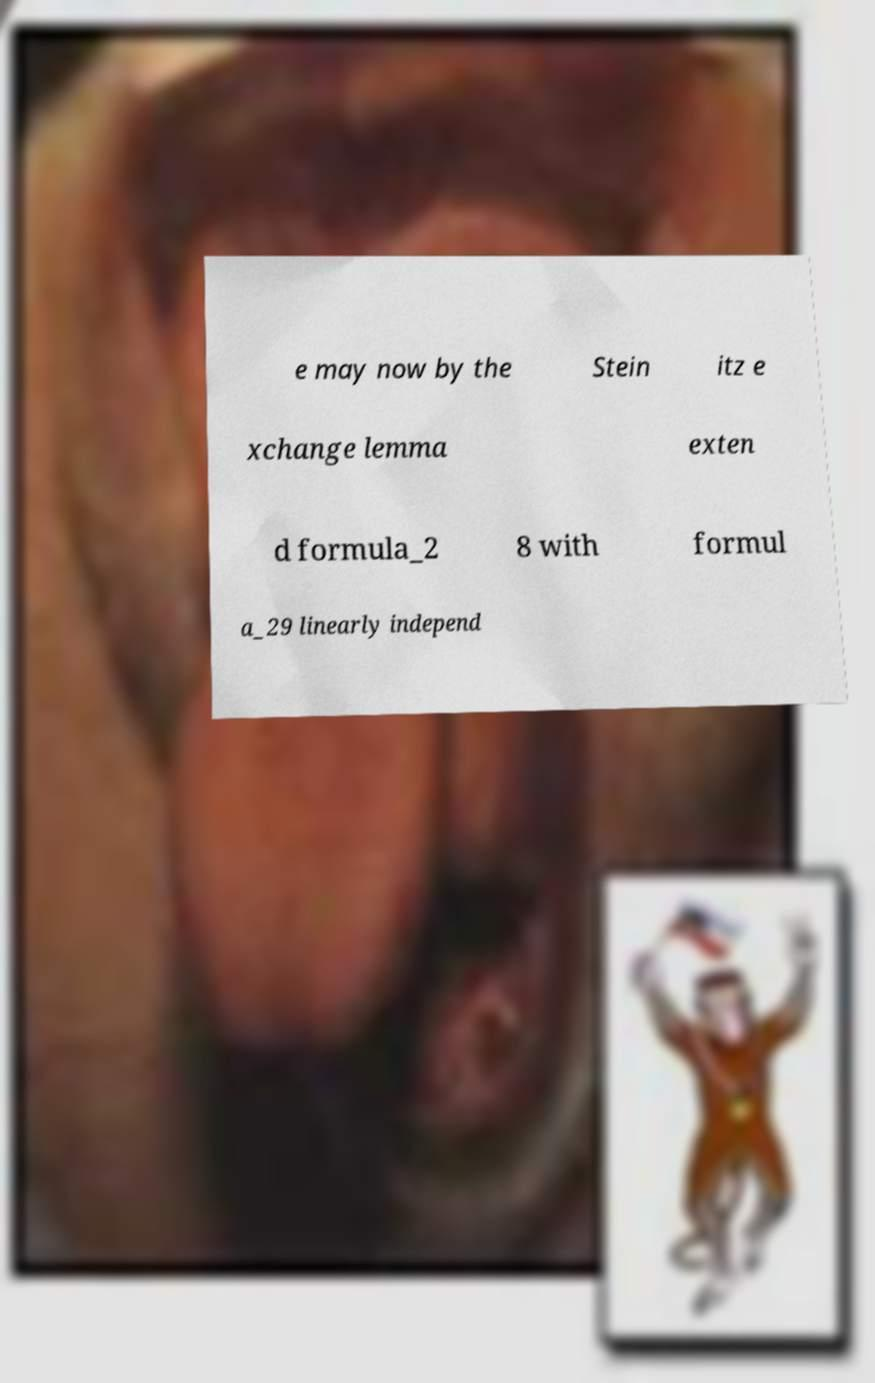Please read and relay the text visible in this image. What does it say? e may now by the Stein itz e xchange lemma exten d formula_2 8 with formul a_29 linearly independ 